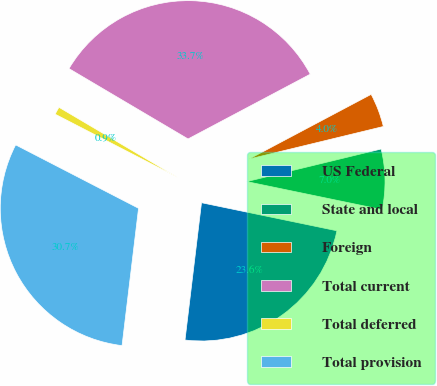Convert chart to OTSL. <chart><loc_0><loc_0><loc_500><loc_500><pie_chart><fcel>US Federal<fcel>State and local<fcel>Foreign<fcel>Total current<fcel>Total deferred<fcel>Total provision<nl><fcel>23.65%<fcel>7.04%<fcel>3.97%<fcel>33.75%<fcel>0.91%<fcel>30.68%<nl></chart> 